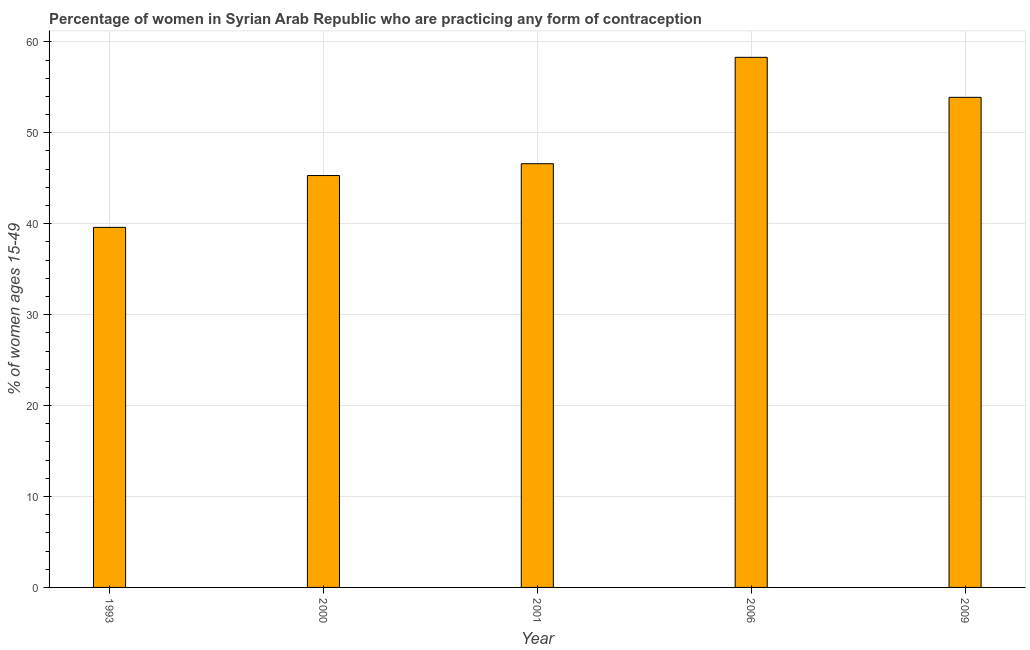Does the graph contain grids?
Your response must be concise. Yes. What is the title of the graph?
Your response must be concise. Percentage of women in Syrian Arab Republic who are practicing any form of contraception. What is the label or title of the Y-axis?
Your answer should be very brief. % of women ages 15-49. What is the contraceptive prevalence in 2009?
Keep it short and to the point. 53.9. Across all years, what is the maximum contraceptive prevalence?
Your answer should be compact. 58.3. Across all years, what is the minimum contraceptive prevalence?
Your response must be concise. 39.6. In which year was the contraceptive prevalence maximum?
Provide a short and direct response. 2006. What is the sum of the contraceptive prevalence?
Give a very brief answer. 243.7. What is the difference between the contraceptive prevalence in 2006 and 2009?
Offer a very short reply. 4.4. What is the average contraceptive prevalence per year?
Keep it short and to the point. 48.74. What is the median contraceptive prevalence?
Provide a succinct answer. 46.6. What is the ratio of the contraceptive prevalence in 2000 to that in 2009?
Make the answer very short. 0.84. Is the sum of the contraceptive prevalence in 1993 and 2001 greater than the maximum contraceptive prevalence across all years?
Provide a short and direct response. Yes. What is the difference between the highest and the lowest contraceptive prevalence?
Your answer should be compact. 18.7. In how many years, is the contraceptive prevalence greater than the average contraceptive prevalence taken over all years?
Your answer should be very brief. 2. How many bars are there?
Give a very brief answer. 5. Are all the bars in the graph horizontal?
Make the answer very short. No. How many years are there in the graph?
Provide a short and direct response. 5. Are the values on the major ticks of Y-axis written in scientific E-notation?
Offer a terse response. No. What is the % of women ages 15-49 in 1993?
Keep it short and to the point. 39.6. What is the % of women ages 15-49 in 2000?
Keep it short and to the point. 45.3. What is the % of women ages 15-49 in 2001?
Provide a short and direct response. 46.6. What is the % of women ages 15-49 in 2006?
Ensure brevity in your answer.  58.3. What is the % of women ages 15-49 in 2009?
Provide a succinct answer. 53.9. What is the difference between the % of women ages 15-49 in 1993 and 2006?
Ensure brevity in your answer.  -18.7. What is the difference between the % of women ages 15-49 in 1993 and 2009?
Keep it short and to the point. -14.3. What is the difference between the % of women ages 15-49 in 2000 and 2009?
Your answer should be very brief. -8.6. What is the difference between the % of women ages 15-49 in 2001 and 2006?
Keep it short and to the point. -11.7. What is the difference between the % of women ages 15-49 in 2006 and 2009?
Make the answer very short. 4.4. What is the ratio of the % of women ages 15-49 in 1993 to that in 2000?
Your answer should be very brief. 0.87. What is the ratio of the % of women ages 15-49 in 1993 to that in 2001?
Provide a succinct answer. 0.85. What is the ratio of the % of women ages 15-49 in 1993 to that in 2006?
Your response must be concise. 0.68. What is the ratio of the % of women ages 15-49 in 1993 to that in 2009?
Offer a very short reply. 0.73. What is the ratio of the % of women ages 15-49 in 2000 to that in 2001?
Provide a short and direct response. 0.97. What is the ratio of the % of women ages 15-49 in 2000 to that in 2006?
Provide a short and direct response. 0.78. What is the ratio of the % of women ages 15-49 in 2000 to that in 2009?
Your answer should be very brief. 0.84. What is the ratio of the % of women ages 15-49 in 2001 to that in 2006?
Ensure brevity in your answer.  0.8. What is the ratio of the % of women ages 15-49 in 2001 to that in 2009?
Ensure brevity in your answer.  0.86. What is the ratio of the % of women ages 15-49 in 2006 to that in 2009?
Offer a very short reply. 1.08. 